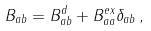<formula> <loc_0><loc_0><loc_500><loc_500>B _ { a b } = B _ { a b } ^ { d } + B _ { a a } ^ { e x } \delta _ { a b } \, ,</formula> 